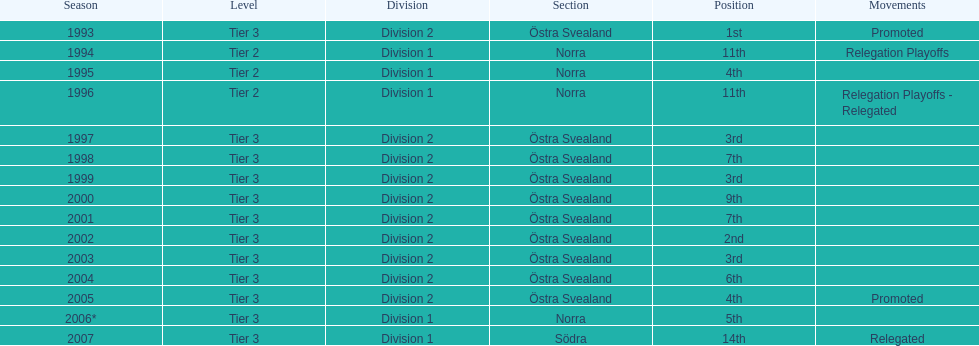Can you parse all the data within this table? {'header': ['Season', 'Level', 'Division', 'Section', 'Position', 'Movements'], 'rows': [['1993', 'Tier 3', 'Division 2', 'Östra Svealand', '1st', 'Promoted'], ['1994', 'Tier 2', 'Division 1', 'Norra', '11th', 'Relegation Playoffs'], ['1995', 'Tier 2', 'Division 1', 'Norra', '4th', ''], ['1996', 'Tier 2', 'Division 1', 'Norra', '11th', 'Relegation Playoffs - Relegated'], ['1997', 'Tier 3', 'Division 2', 'Östra Svealand', '3rd', ''], ['1998', 'Tier 3', 'Division 2', 'Östra Svealand', '7th', ''], ['1999', 'Tier 3', 'Division 2', 'Östra Svealand', '3rd', ''], ['2000', 'Tier 3', 'Division 2', 'Östra Svealand', '9th', ''], ['2001', 'Tier 3', 'Division 2', 'Östra Svealand', '7th', ''], ['2002', 'Tier 3', 'Division 2', 'Östra Svealand', '2nd', ''], ['2003', 'Tier 3', 'Division 2', 'Östra Svealand', '3rd', ''], ['2004', 'Tier 3', 'Division 2', 'Östra Svealand', '6th', ''], ['2005', 'Tier 3', 'Division 2', 'Östra Svealand', '4th', 'Promoted'], ['2006*', 'Tier 3', 'Division 1', 'Norra', '5th', ''], ['2007', 'Tier 3', 'Division 1', 'Södra', '14th', 'Relegated']]} After finishing 9th in their division in 2000, was their performance in the following season better or worse? Better. 